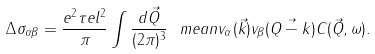Convert formula to latex. <formula><loc_0><loc_0><loc_500><loc_500>\Delta \sigma _ { \alpha \beta } = \frac { e ^ { 2 } \tau e l ^ { 2 } } { \pi } \int \frac { d \vec { Q } } { ( 2 \pi ) ^ { 3 } } \ m e a n { v _ { \alpha } ( \vec { k } ) v _ { \beta } ( \vec { Q - k } ) } C ( \vec { Q } , \omega ) .</formula> 